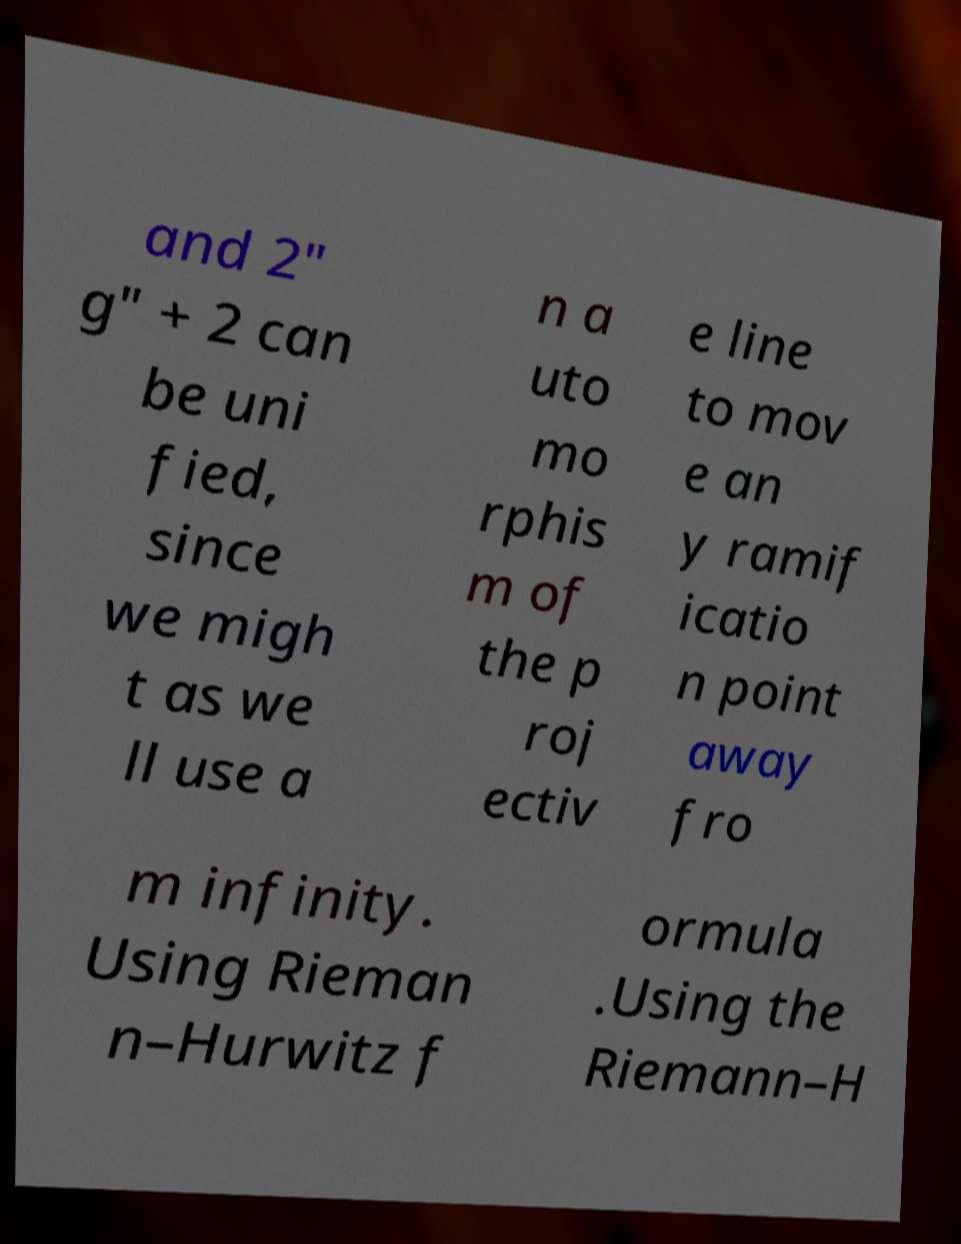There's text embedded in this image that I need extracted. Can you transcribe it verbatim? and 2" g" + 2 can be uni fied, since we migh t as we ll use a n a uto mo rphis m of the p roj ectiv e line to mov e an y ramif icatio n point away fro m infinity. Using Rieman n–Hurwitz f ormula .Using the Riemann–H 